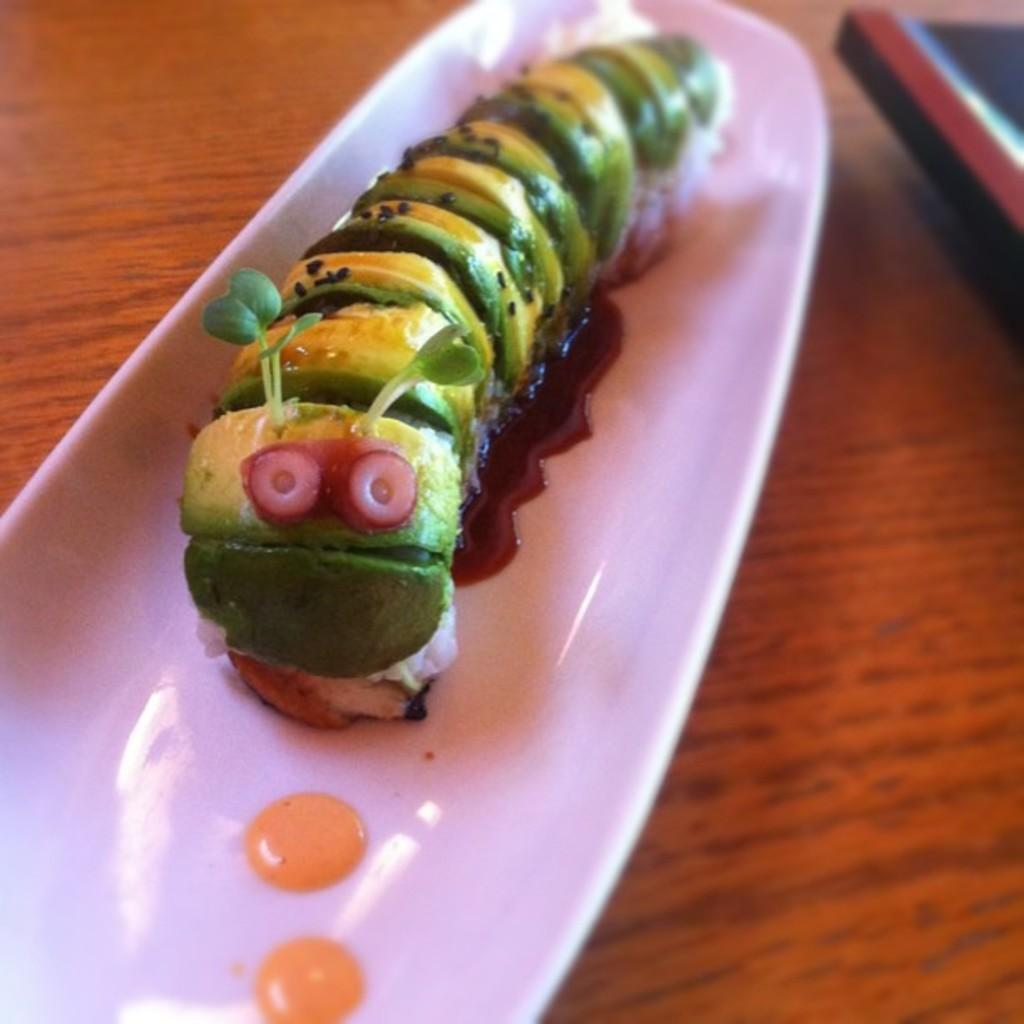What is the main subject of the image? There is a food item in the image. How is the food item presented? The food item is in a bowl. What piece of furniture is visible in the image? There is a table in the image. What type of canvas is being used to paint the food item in the image? There is no canvas or painting present in the image; it is a photograph of a food item in a bowl on a table. 